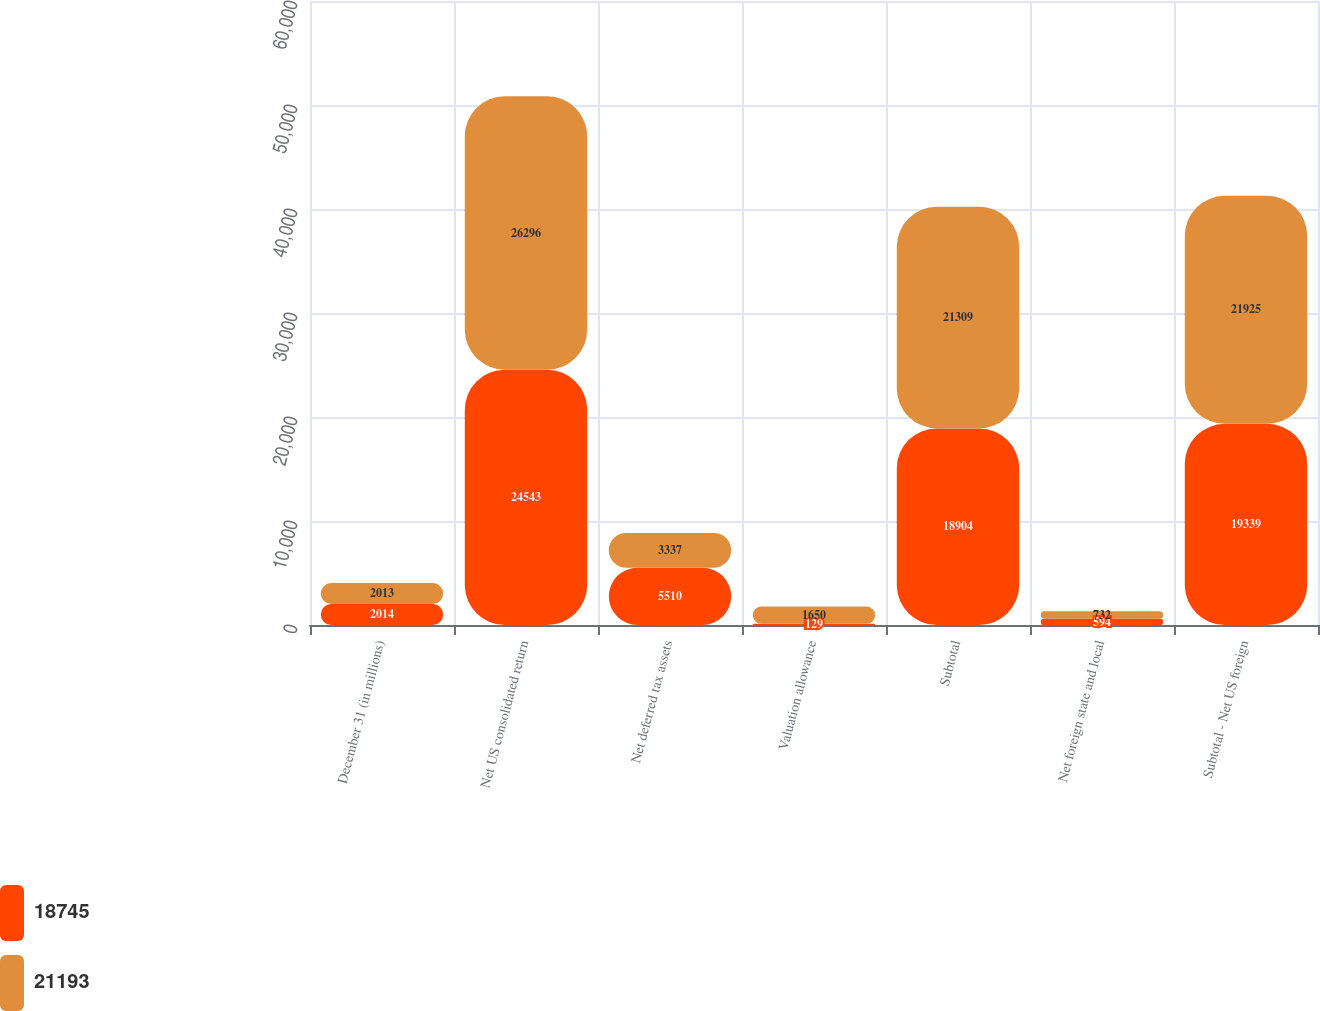Convert chart to OTSL. <chart><loc_0><loc_0><loc_500><loc_500><stacked_bar_chart><ecel><fcel>December 31 (in millions)<fcel>Net US consolidated return<fcel>Net deferred tax assets<fcel>Valuation allowance<fcel>Subtotal<fcel>Net foreign state and local<fcel>Subtotal - Net US foreign<nl><fcel>18745<fcel>2014<fcel>24543<fcel>5510<fcel>129<fcel>18904<fcel>594<fcel>19339<nl><fcel>21193<fcel>2013<fcel>26296<fcel>3337<fcel>1650<fcel>21309<fcel>732<fcel>21925<nl></chart> 